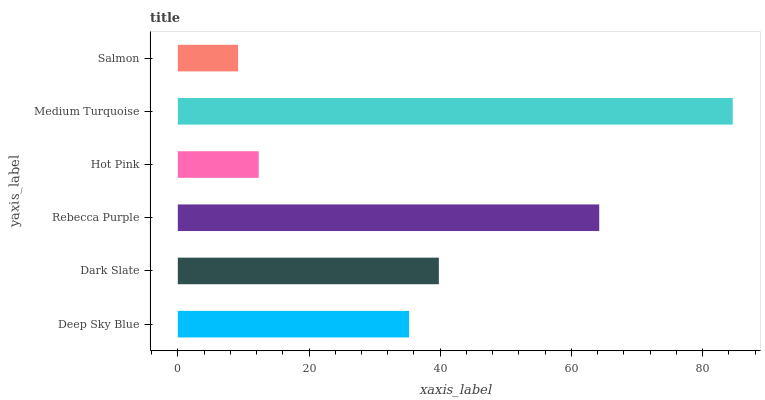Is Salmon the minimum?
Answer yes or no. Yes. Is Medium Turquoise the maximum?
Answer yes or no. Yes. Is Dark Slate the minimum?
Answer yes or no. No. Is Dark Slate the maximum?
Answer yes or no. No. Is Dark Slate greater than Deep Sky Blue?
Answer yes or no. Yes. Is Deep Sky Blue less than Dark Slate?
Answer yes or no. Yes. Is Deep Sky Blue greater than Dark Slate?
Answer yes or no. No. Is Dark Slate less than Deep Sky Blue?
Answer yes or no. No. Is Dark Slate the high median?
Answer yes or no. Yes. Is Deep Sky Blue the low median?
Answer yes or no. Yes. Is Salmon the high median?
Answer yes or no. No. Is Salmon the low median?
Answer yes or no. No. 